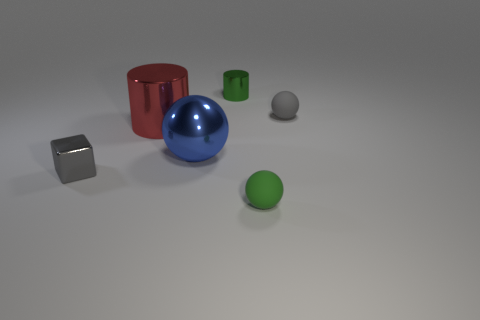There is a blue thing that is made of the same material as the red thing; what is its size?
Make the answer very short. Large. What number of things are either tiny metal things that are on the right side of the red cylinder or small things that are in front of the small green metal thing?
Keep it short and to the point. 4. Is the number of tiny matte objects behind the gray matte object the same as the number of tiny shiny objects right of the small green cylinder?
Offer a very short reply. Yes. The tiny matte thing that is behind the tiny green matte sphere is what color?
Your response must be concise. Gray. Does the tiny cylinder have the same color as the large metallic object in front of the large red metal object?
Your answer should be compact. No. Is the number of small red metallic cylinders less than the number of small green cylinders?
Offer a terse response. Yes. There is a thing that is left of the large cylinder; is it the same color as the big metallic cylinder?
Ensure brevity in your answer.  No. How many green balls have the same size as the block?
Provide a short and direct response. 1. Are there any tiny balls that have the same color as the tiny cube?
Make the answer very short. Yes. Do the big sphere and the green sphere have the same material?
Ensure brevity in your answer.  No. 